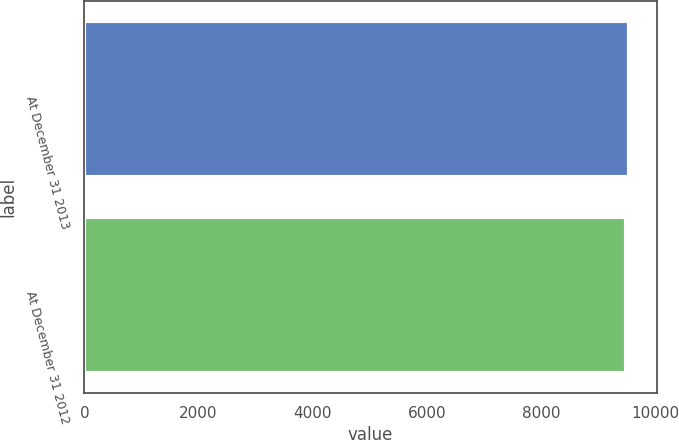Convert chart. <chart><loc_0><loc_0><loc_500><loc_500><bar_chart><fcel>At December 31 2013<fcel>At December 31 2012<nl><fcel>9545<fcel>9479<nl></chart> 